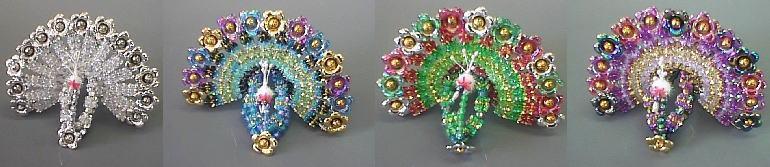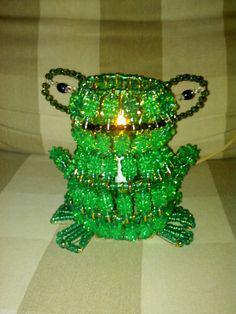The first image is the image on the left, the second image is the image on the right. Given the left and right images, does the statement "One safety pin jewelry item features a heart design using red, white, and blue beads." hold true? Answer yes or no. No. The first image is the image on the left, the second image is the image on the right. For the images displayed, is the sentence "There is a heart pattern made of beads in at least one of the images." factually correct? Answer yes or no. No. 